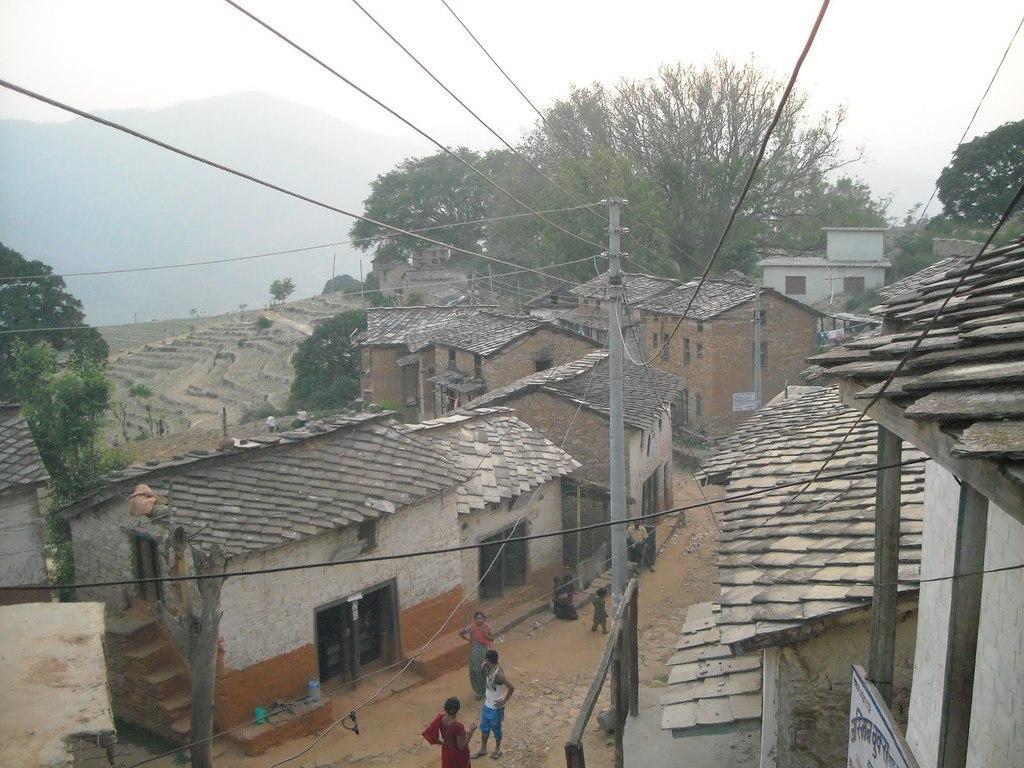Describe this image in one or two sentences. In this picture we can see some people are on the road, name board, poles, wires, trees, buildings, mountains, some objects and in the background we can see the sky. 